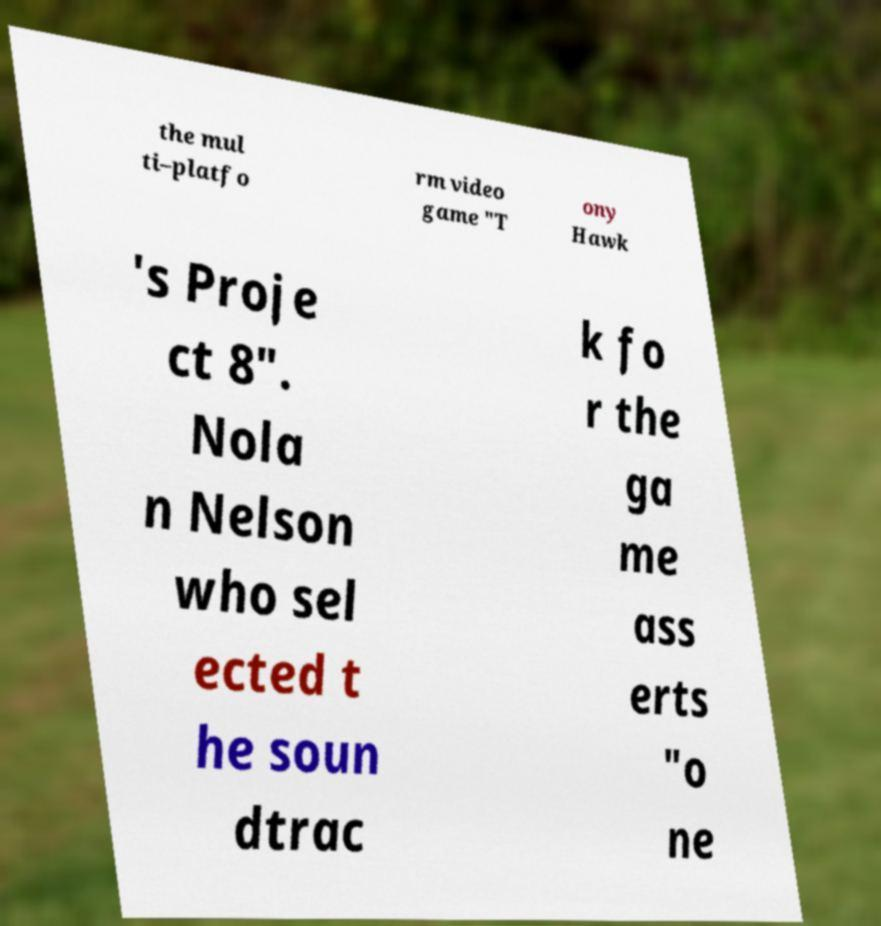Please read and relay the text visible in this image. What does it say? the mul ti–platfo rm video game "T ony Hawk 's Proje ct 8". Nola n Nelson who sel ected t he soun dtrac k fo r the ga me ass erts "o ne 